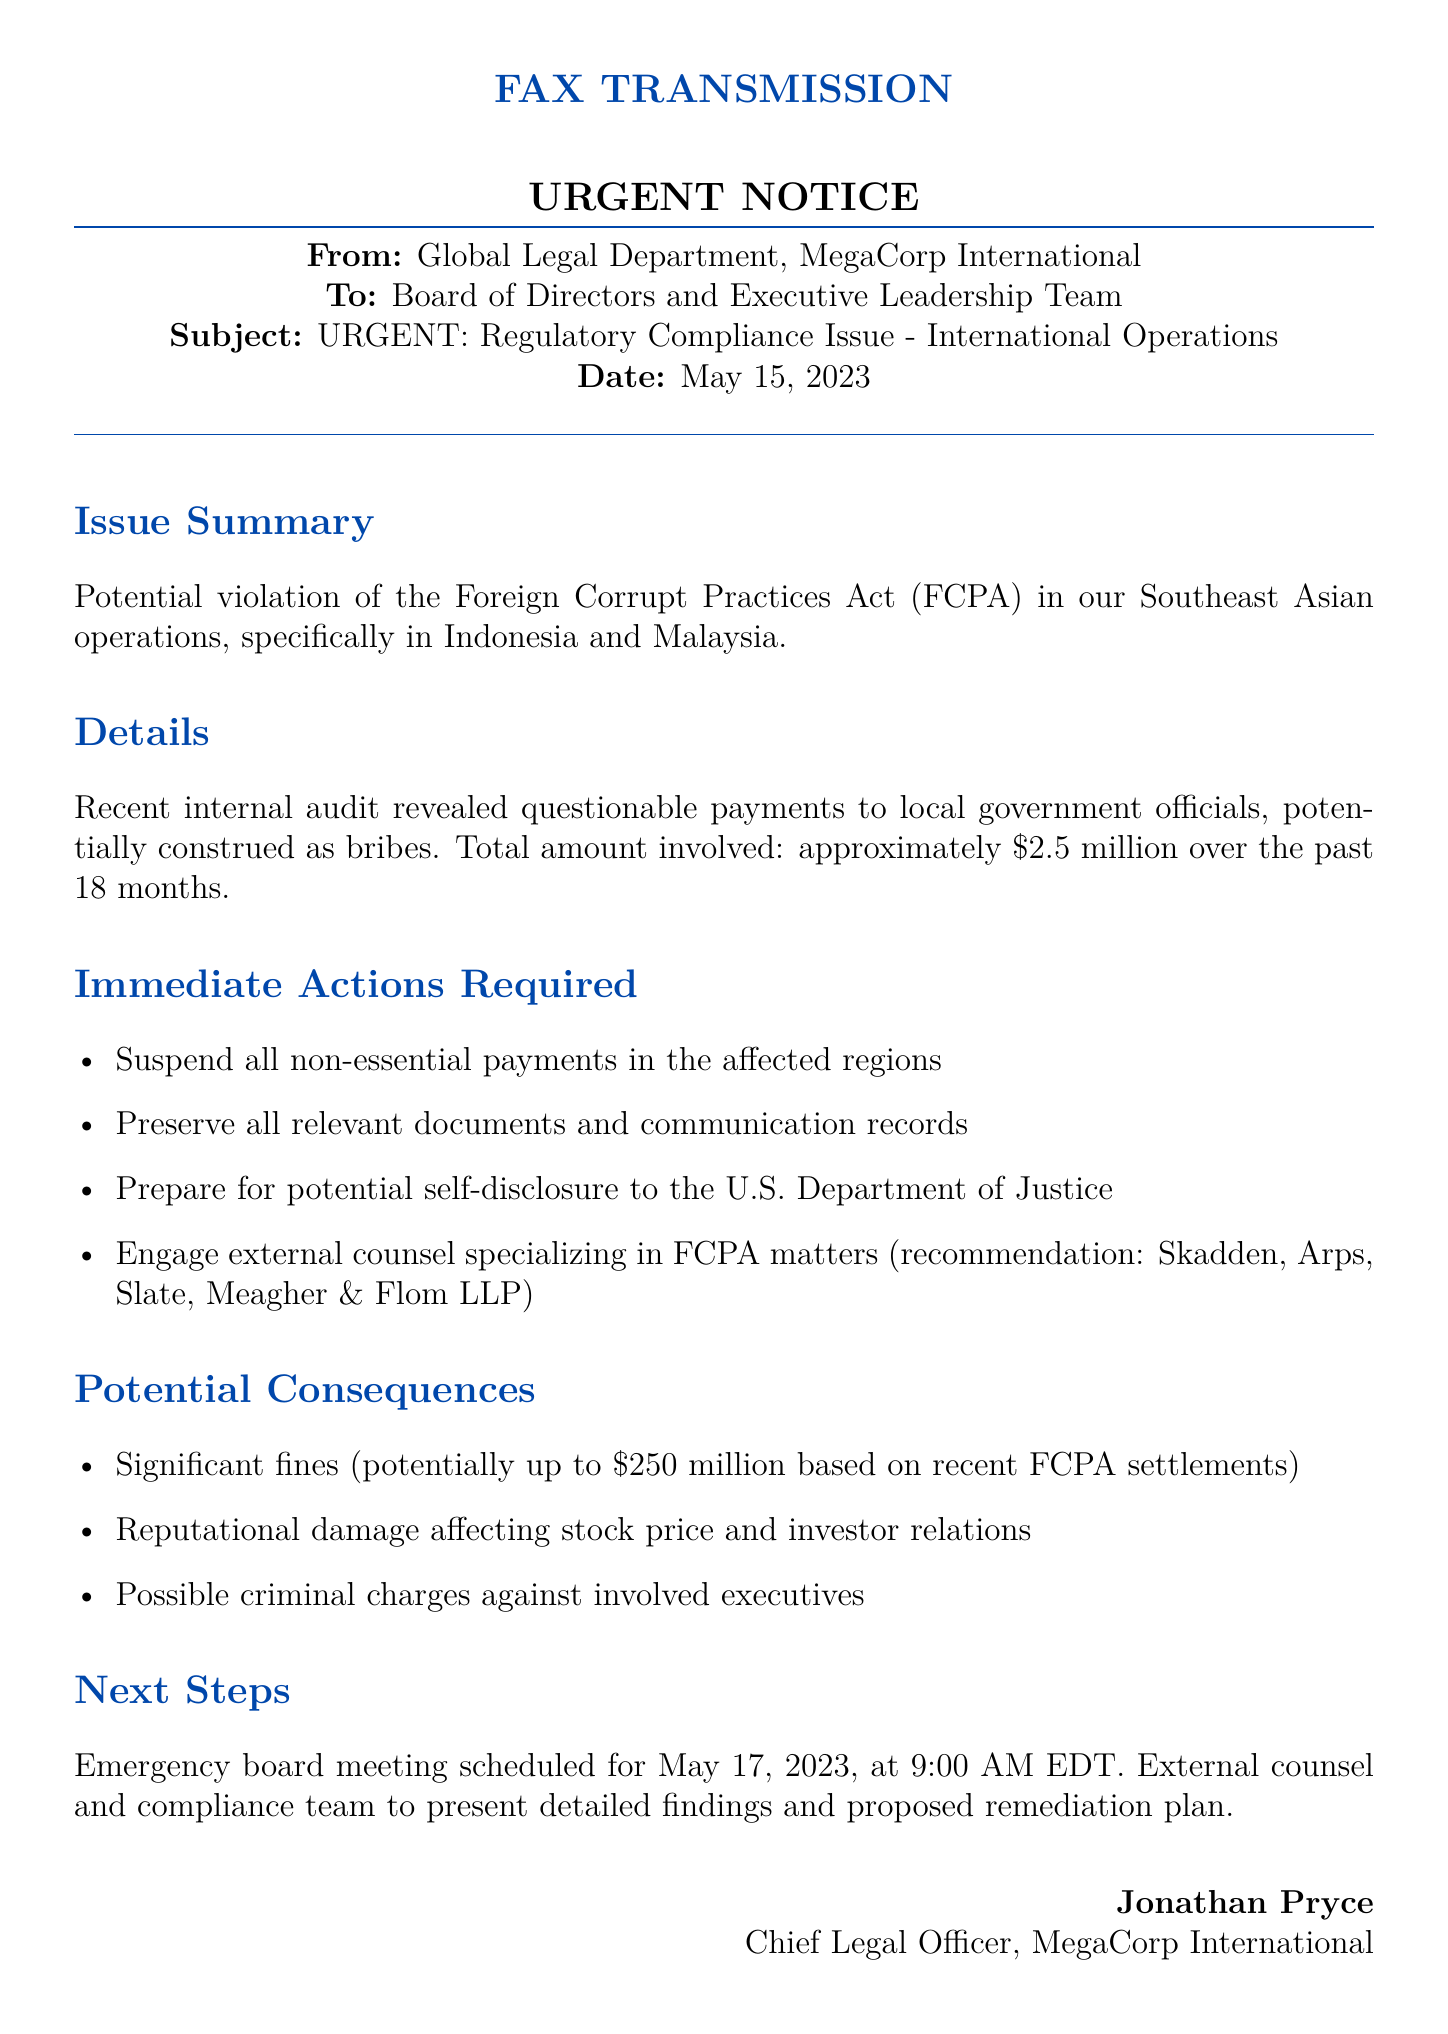What is the date of the fax? The date of the fax is stated in the header of the document.
Answer: May 15, 2023 What is the total amount involved in the questionable payments? The total amount of questionable payments is mentioned in the details section.
Answer: approximately $2.5 million Who is the Chief Legal Officer? The Chief Legal Officer is indicated at the end of the fax.
Answer: Jonathan Pryce When is the emergency board meeting scheduled? The schedule of the emergency board meeting can be found in the next steps section.
Answer: May 17, 2023, at 9:00 AM EDT What act is potentially violated in the Southeast Asian operations? The specific act being referred to is mentioned in the issue summary.
Answer: Foreign Corrupt Practices Act (FCPA) What actions are required immediately? The document lists actions in the "Immediate Actions Required" section.
Answer: Suspend all non-essential payments in the affected regions What could be a potential fine amount based on recent settlements? The potential fine amount is detailed under "Potential Consequences."
Answer: up to $250 million Which law firm is recommended for engagement? The recommended firm is listed under "Immediate Actions Required."
Answer: Skadden, Arps, Slate, Meagher & Flom LLP 